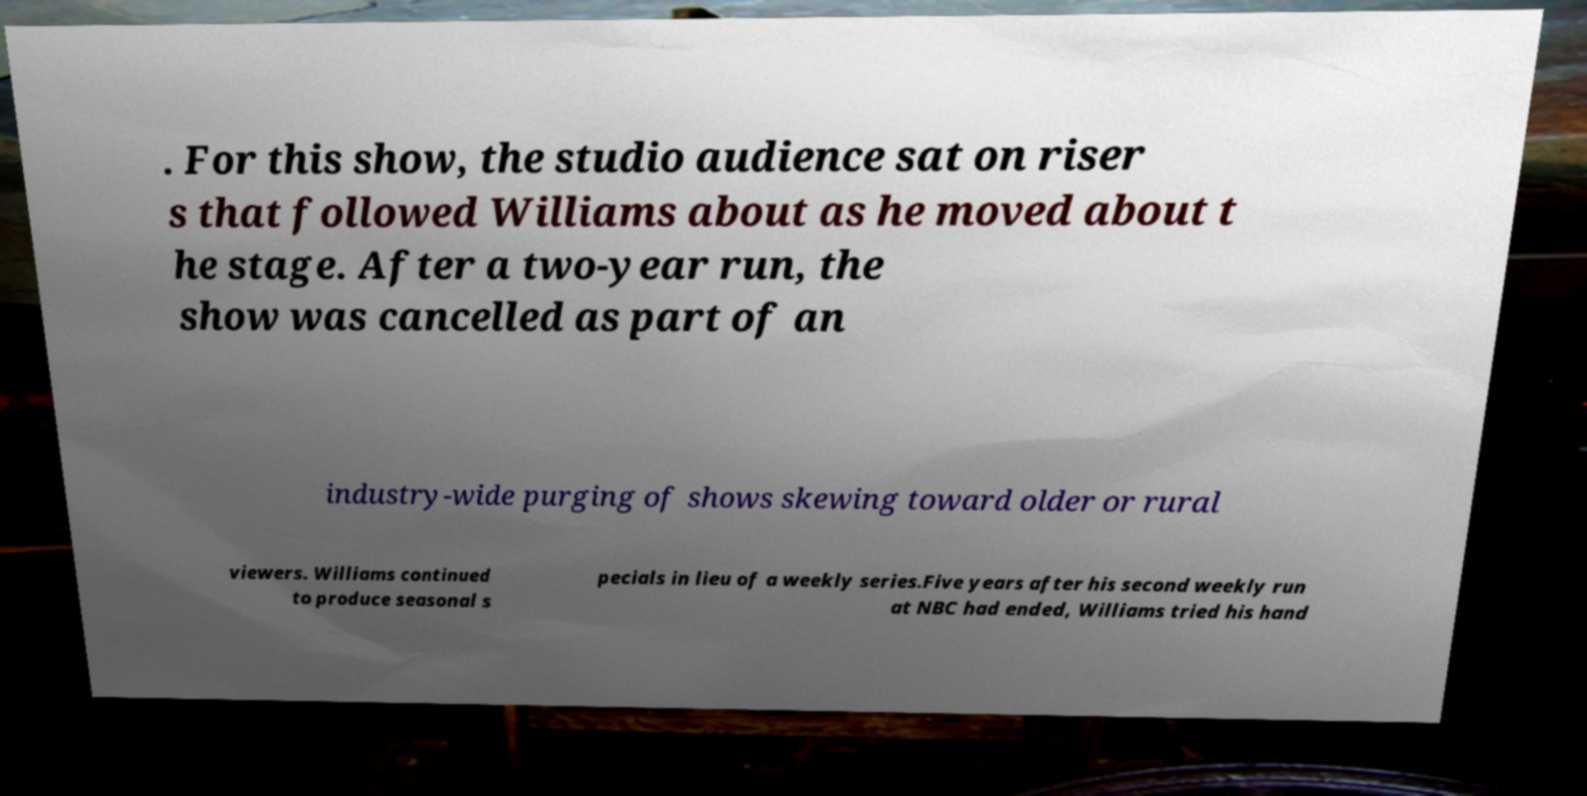What messages or text are displayed in this image? I need them in a readable, typed format. . For this show, the studio audience sat on riser s that followed Williams about as he moved about t he stage. After a two-year run, the show was cancelled as part of an industry-wide purging of shows skewing toward older or rural viewers. Williams continued to produce seasonal s pecials in lieu of a weekly series.Five years after his second weekly run at NBC had ended, Williams tried his hand 